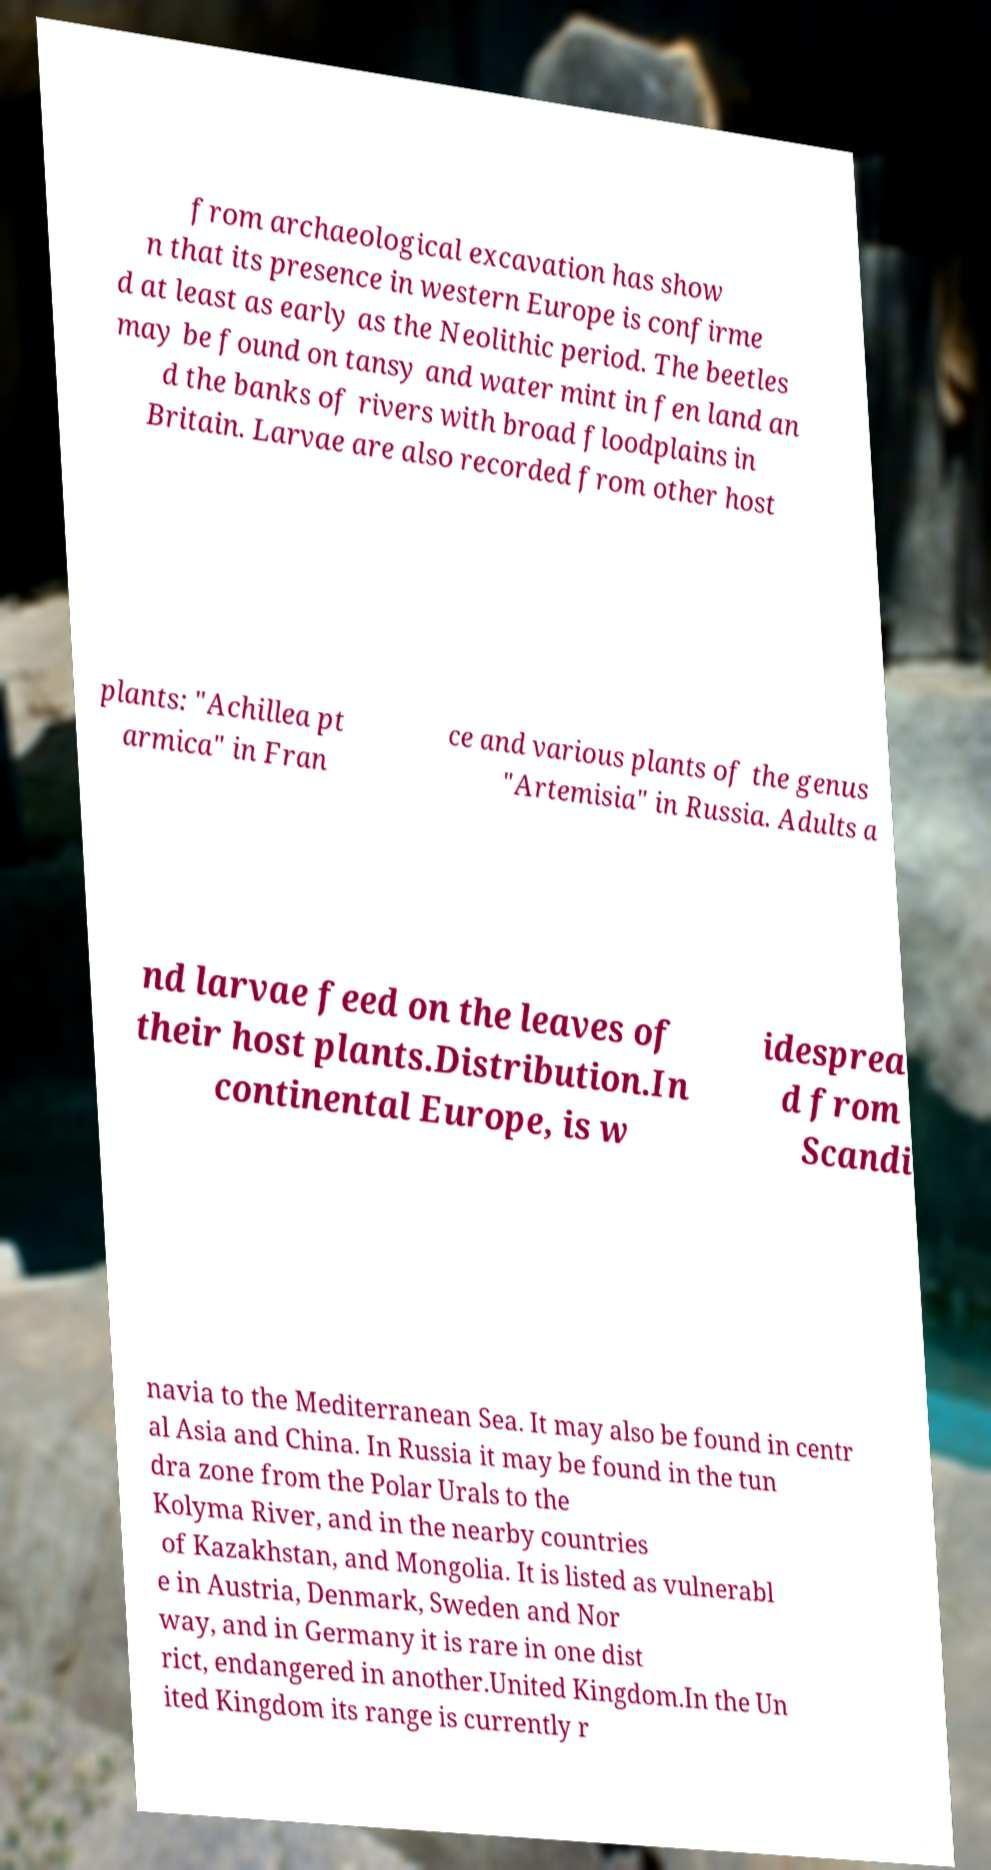What messages or text are displayed in this image? I need them in a readable, typed format. from archaeological excavation has show n that its presence in western Europe is confirme d at least as early as the Neolithic period. The beetles may be found on tansy and water mint in fen land an d the banks of rivers with broad floodplains in Britain. Larvae are also recorded from other host plants: "Achillea pt armica" in Fran ce and various plants of the genus "Artemisia" in Russia. Adults a nd larvae feed on the leaves of their host plants.Distribution.In continental Europe, is w idesprea d from Scandi navia to the Mediterranean Sea. It may also be found in centr al Asia and China. In Russia it may be found in the tun dra zone from the Polar Urals to the Kolyma River, and in the nearby countries of Kazakhstan, and Mongolia. It is listed as vulnerabl e in Austria, Denmark, Sweden and Nor way, and in Germany it is rare in one dist rict, endangered in another.United Kingdom.In the Un ited Kingdom its range is currently r 